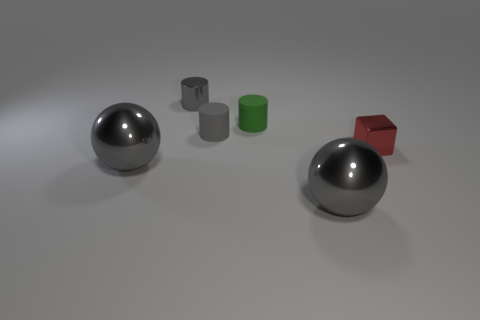Subtract all red cubes. How many gray cylinders are left? 2 Add 1 large gray balls. How many objects exist? 7 Subtract all spheres. How many objects are left? 4 Add 3 large metal objects. How many large metal objects are left? 5 Add 6 big purple objects. How many big purple objects exist? 6 Subtract 0 blue balls. How many objects are left? 6 Subtract all gray cylinders. Subtract all tiny gray objects. How many objects are left? 2 